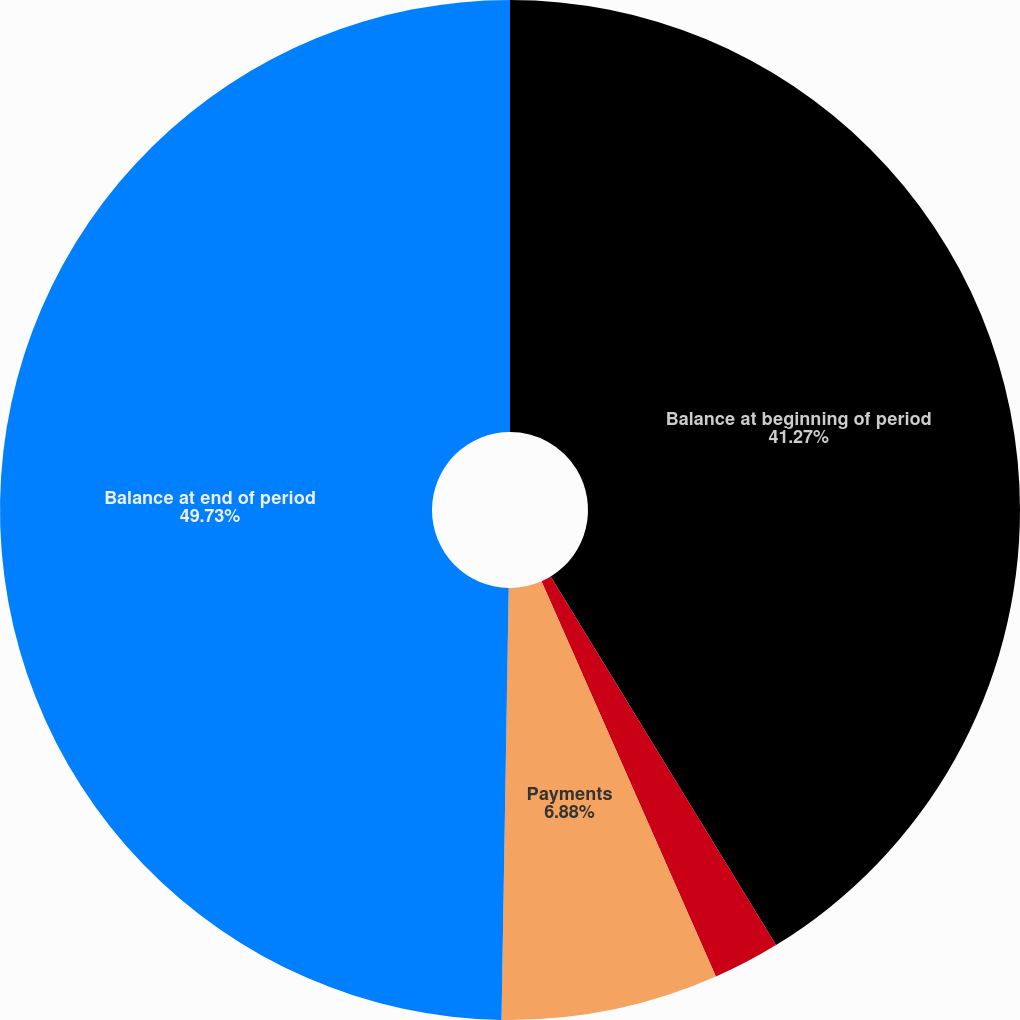<chart> <loc_0><loc_0><loc_500><loc_500><pie_chart><fcel>Balance at beginning of period<fcel>Accretion<fcel>Payments<fcel>Balance at end of period<nl><fcel>41.27%<fcel>2.12%<fcel>6.88%<fcel>49.74%<nl></chart> 